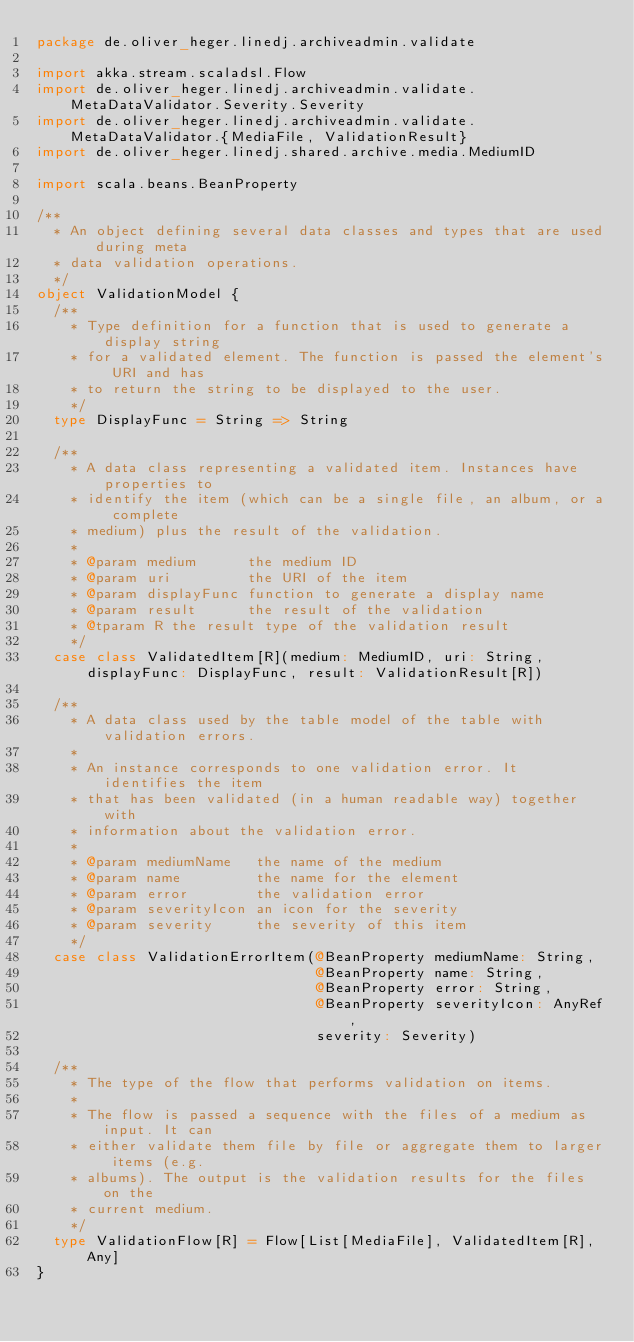Convert code to text. <code><loc_0><loc_0><loc_500><loc_500><_Scala_>package de.oliver_heger.linedj.archiveadmin.validate

import akka.stream.scaladsl.Flow
import de.oliver_heger.linedj.archiveadmin.validate.MetaDataValidator.Severity.Severity
import de.oliver_heger.linedj.archiveadmin.validate.MetaDataValidator.{MediaFile, ValidationResult}
import de.oliver_heger.linedj.shared.archive.media.MediumID

import scala.beans.BeanProperty

/**
  * An object defining several data classes and types that are used during meta
  * data validation operations.
  */
object ValidationModel {
  /**
    * Type definition for a function that is used to generate a display string
    * for a validated element. The function is passed the element's URI and has
    * to return the string to be displayed to the user.
    */
  type DisplayFunc = String => String

  /**
    * A data class representing a validated item. Instances have properties to
    * identify the item (which can be a single file, an album, or a complete
    * medium) plus the result of the validation.
    *
    * @param medium      the medium ID
    * @param uri         the URI of the item
    * @param displayFunc function to generate a display name
    * @param result      the result of the validation
    * @tparam R the result type of the validation result
    */
  case class ValidatedItem[R](medium: MediumID, uri: String, displayFunc: DisplayFunc, result: ValidationResult[R])

  /**
    * A data class used by the table model of the table with validation errors.
    *
    * An instance corresponds to one validation error. It identifies the item
    * that has been validated (in a human readable way) together with
    * information about the validation error.
    *
    * @param mediumName   the name of the medium
    * @param name         the name for the element
    * @param error        the validation error
    * @param severityIcon an icon for the severity
    * @param severity     the severity of this item
    */
  case class ValidationErrorItem(@BeanProperty mediumName: String,
                                 @BeanProperty name: String,
                                 @BeanProperty error: String,
                                 @BeanProperty severityIcon: AnyRef,
                                 severity: Severity)

  /**
    * The type of the flow that performs validation on items.
    *
    * The flow is passed a sequence with the files of a medium as input. It can
    * either validate them file by file or aggregate them to larger items (e.g.
    * albums). The output is the validation results for the files on the
    * current medium.
    */
  type ValidationFlow[R] = Flow[List[MediaFile], ValidatedItem[R], Any]
}
</code> 